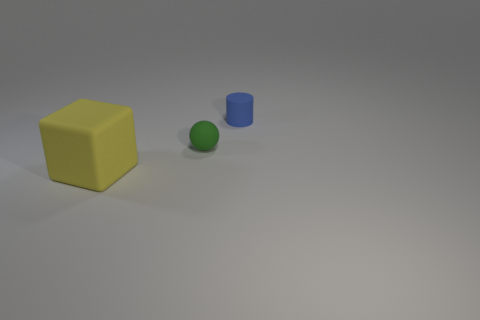How many other things are made of the same material as the small sphere?
Offer a terse response. 2. What number of cylinders are the same size as the blue matte object?
Your answer should be compact. 0. How many metal things are big cubes or cyan things?
Ensure brevity in your answer.  0. What material is the blue object?
Provide a succinct answer. Rubber. How many green matte spheres are in front of the large yellow rubber object?
Provide a succinct answer. 0. How many other matte things are the same shape as the large object?
Ensure brevity in your answer.  0. How many big objects are either blue cylinders or rubber objects?
Provide a short and direct response. 1. Are there any blocks that have the same material as the cylinder?
Provide a succinct answer. Yes. What number of brown objects are small matte cylinders or big objects?
Keep it short and to the point. 0. Are there more green matte objects that are to the right of the blue thing than large purple metal spheres?
Ensure brevity in your answer.  No. 